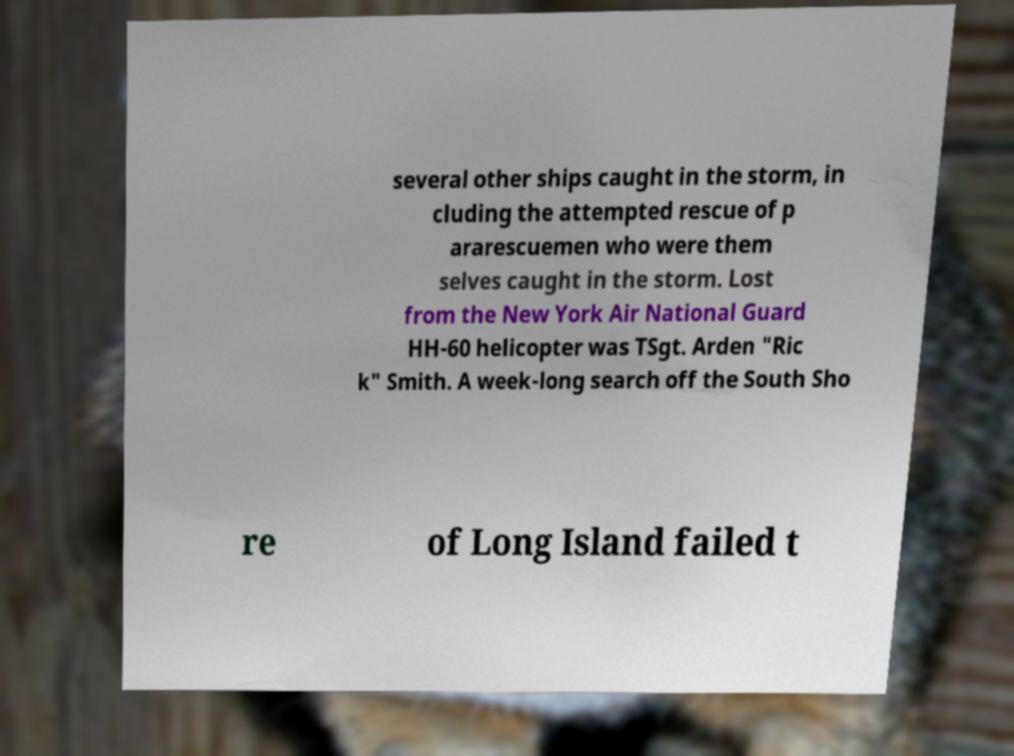I need the written content from this picture converted into text. Can you do that? several other ships caught in the storm, in cluding the attempted rescue of p ararescuemen who were them selves caught in the storm. Lost from the New York Air National Guard HH-60 helicopter was TSgt. Arden "Ric k" Smith. A week-long search off the South Sho re of Long Island failed t 